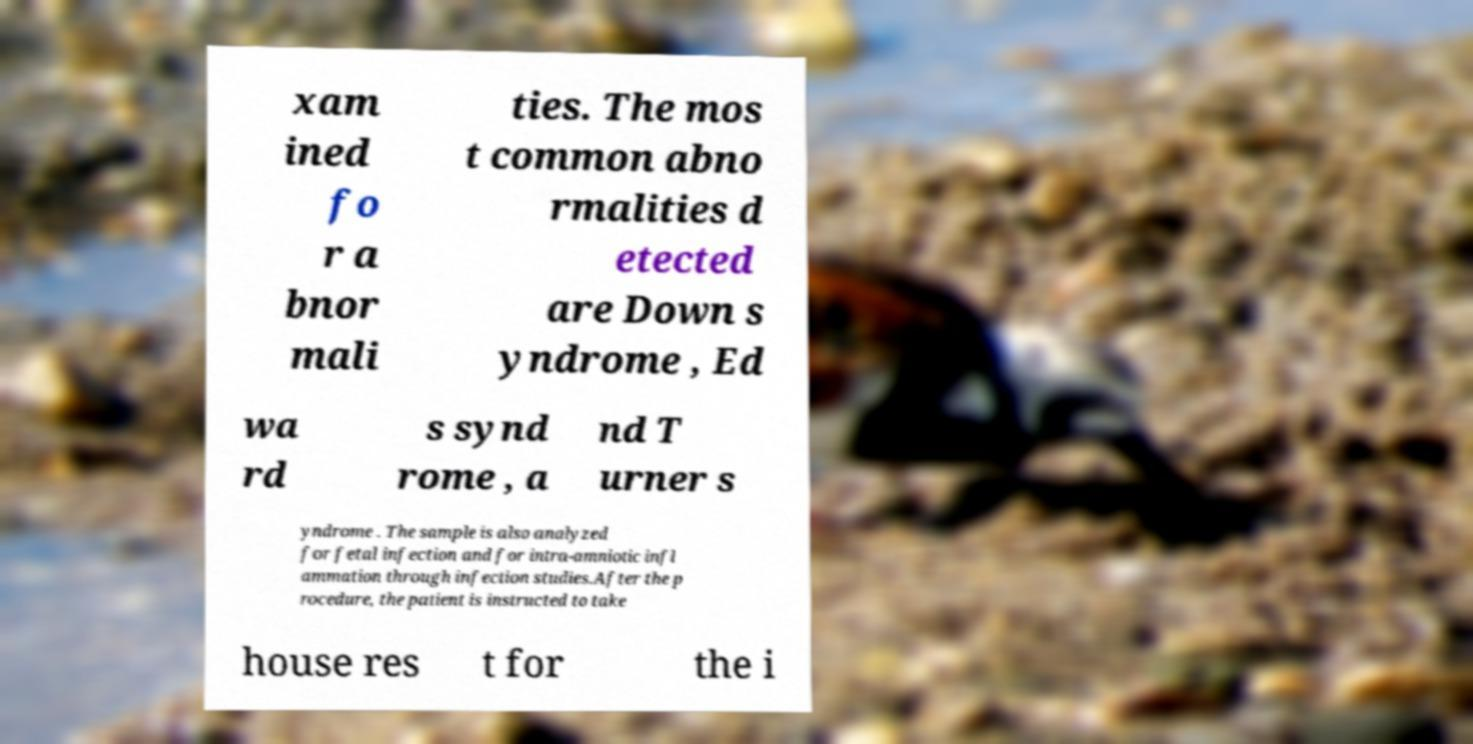Please identify and transcribe the text found in this image. xam ined fo r a bnor mali ties. The mos t common abno rmalities d etected are Down s yndrome , Ed wa rd s synd rome , a nd T urner s yndrome . The sample is also analyzed for fetal infection and for intra-amniotic infl ammation through infection studies.After the p rocedure, the patient is instructed to take house res t for the i 